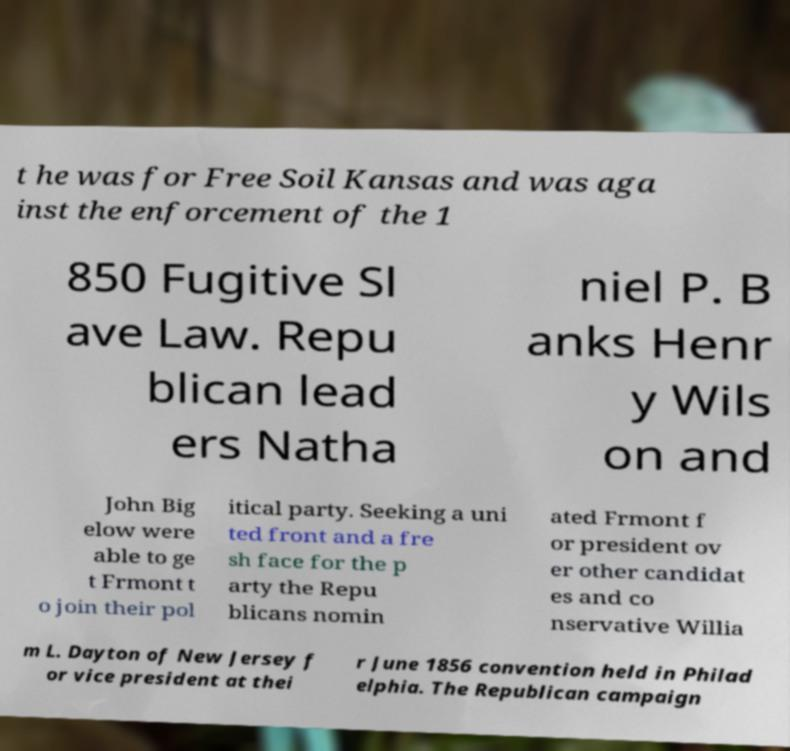Please read and relay the text visible in this image. What does it say? t he was for Free Soil Kansas and was aga inst the enforcement of the 1 850 Fugitive Sl ave Law. Repu blican lead ers Natha niel P. B anks Henr y Wils on and John Big elow were able to ge t Frmont t o join their pol itical party. Seeking a uni ted front and a fre sh face for the p arty the Repu blicans nomin ated Frmont f or president ov er other candidat es and co nservative Willia m L. Dayton of New Jersey f or vice president at thei r June 1856 convention held in Philad elphia. The Republican campaign 